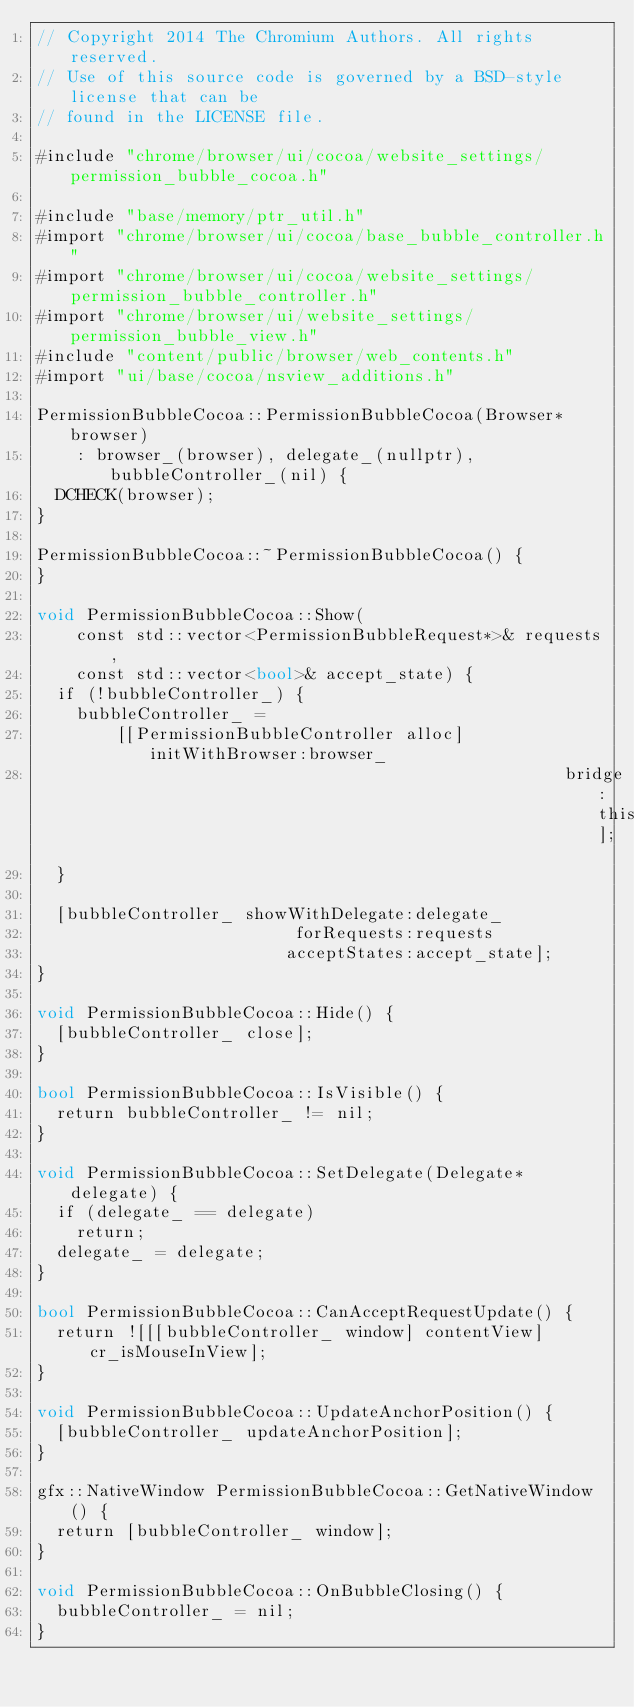Convert code to text. <code><loc_0><loc_0><loc_500><loc_500><_ObjectiveC_>// Copyright 2014 The Chromium Authors. All rights reserved.
// Use of this source code is governed by a BSD-style license that can be
// found in the LICENSE file.

#include "chrome/browser/ui/cocoa/website_settings/permission_bubble_cocoa.h"

#include "base/memory/ptr_util.h"
#import "chrome/browser/ui/cocoa/base_bubble_controller.h"
#import "chrome/browser/ui/cocoa/website_settings/permission_bubble_controller.h"
#import "chrome/browser/ui/website_settings/permission_bubble_view.h"
#include "content/public/browser/web_contents.h"
#import "ui/base/cocoa/nsview_additions.h"

PermissionBubbleCocoa::PermissionBubbleCocoa(Browser* browser)
    : browser_(browser), delegate_(nullptr), bubbleController_(nil) {
  DCHECK(browser);
}

PermissionBubbleCocoa::~PermissionBubbleCocoa() {
}

void PermissionBubbleCocoa::Show(
    const std::vector<PermissionBubbleRequest*>& requests,
    const std::vector<bool>& accept_state) {
  if (!bubbleController_) {
    bubbleController_ =
        [[PermissionBubbleController alloc] initWithBrowser:browser_
                                                     bridge:this];
  }

  [bubbleController_ showWithDelegate:delegate_
                          forRequests:requests
                         acceptStates:accept_state];
}

void PermissionBubbleCocoa::Hide() {
  [bubbleController_ close];
}

bool PermissionBubbleCocoa::IsVisible() {
  return bubbleController_ != nil;
}

void PermissionBubbleCocoa::SetDelegate(Delegate* delegate) {
  if (delegate_ == delegate)
    return;
  delegate_ = delegate;
}

bool PermissionBubbleCocoa::CanAcceptRequestUpdate() {
  return ![[[bubbleController_ window] contentView] cr_isMouseInView];
}

void PermissionBubbleCocoa::UpdateAnchorPosition() {
  [bubbleController_ updateAnchorPosition];
}

gfx::NativeWindow PermissionBubbleCocoa::GetNativeWindow() {
  return [bubbleController_ window];
}

void PermissionBubbleCocoa::OnBubbleClosing() {
  bubbleController_ = nil;
}
</code> 